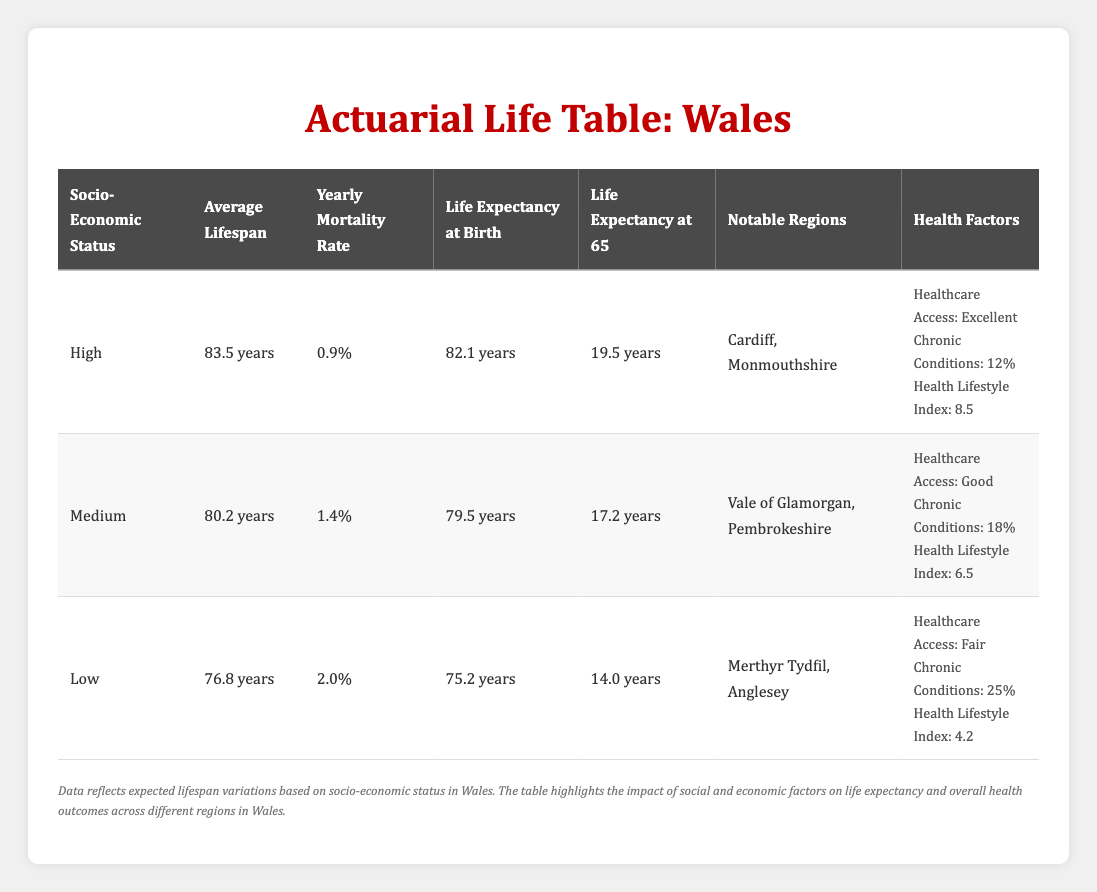What is the average lifespan for individuals in the high socio-economic status group? The table clearly states that the average lifespan for the high socio-economic status group is listed as 83.5 years.
Answer: 83.5 years Which population group has the lowest yearly mortality rate? By examining the yearly mortality rates in the table, the high socio-economic status group has the lowest at 0.009, compared to 0.014 for medium and 0.020 for low.
Answer: High What is the life expectancy at birth for individuals in the low socio-economic group? The table specifies that the life expectancy at birth for the low socio-economic status group is 75.2 years.
Answer: 75.2 years How much higher is the average lifespan of the high socio-economic group compared to the low socio-economic group? The average lifespan of the high group is 83.5 years, while the low group is 76.8 years. The difference is calculated as 83.5 - 76.8 = 6.7 years.
Answer: 6.7 years Is there evidence that access to healthcare is categorized as 'Excellent' among the low socio-economic status group? According to the table, the low socio-economic status group has healthcare access marked as 'Fair', indicating that the statement is false.
Answer: No What factors contribute to the variation in life expectancy between the high and low socio-economic status groups? The table indicates that higher socio-economic status is associated with better healthcare access, lower prevalence of chronic conditions (12% vs. 25%), and a higher health lifestyle index (8.5 vs. 4.2), all of which contribute to a significantly longer life expectancy in the high group.
Answer: Better healthcare, lower chronic conditions, higher health lifestyle index What is the average life expectancy at age 65 for individuals in the medium socio-economic group? The table lists the life expectancy at age 65 for the medium socio-economic group as 17.2 years.
Answer: 17.2 years How does the prevalence of chronic conditions compare between the different socio-economic groups? The high group has a 12% prevalence, medium has 18%, and low has 25%. This shows that as socio-economic status decreases, the prevalence of chronic conditions increases.
Answer: Increases with decreasing socio-economic status What is the overall Health Lifestyle Index for individuals in the high socio-economic group compared to the low? The table shows a Health Lifestyle Index of 8.5 for the high group and 4.2 for the low group. The difference indicates that individuals in the high group maintain a considerably healthier lifestyle.
Answer: Higher in high group 